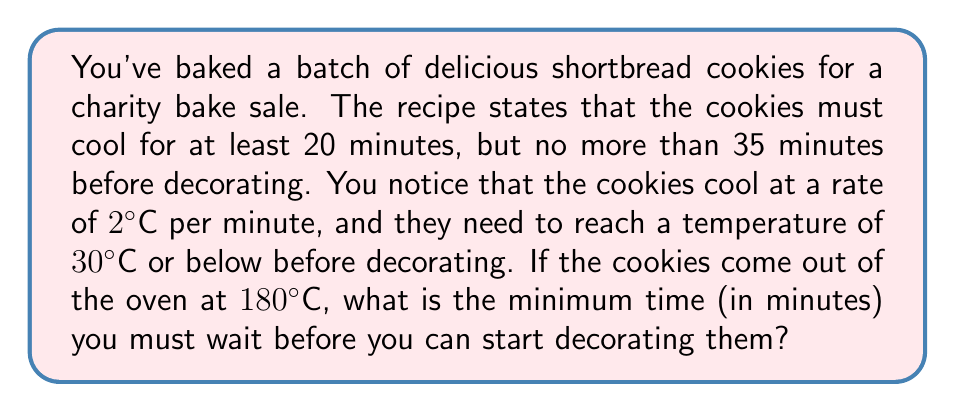Give your solution to this math problem. Let's approach this step-by-step:

1) First, we need to determine how many degrees the cookies need to cool:
   Initial temperature: $180°C$
   Target temperature: $30°C$
   Temperature difference: $180°C - 30°C = 150°C$

2) Now, we know the cooling rate is $2°C$ per minute. To find the time, we can use the formula:
   $\text{Time} = \frac{\text{Temperature difference}}{\text{Cooling rate}}$

3) Plugging in our values:
   $\text{Time} = \frac{150°C}{2°C/\text{min}} = 75 \text{ minutes}$

4) However, we need to consider the constraints given in the recipe:
   Minimum cooling time: 20 minutes
   Maximum cooling time: 35 minutes

5) The calculated time (75 minutes) exceeds the maximum allowed time (35 minutes).

6) Therefore, we must use the maximum allowed time of 35 minutes.
Answer: 35 minutes 